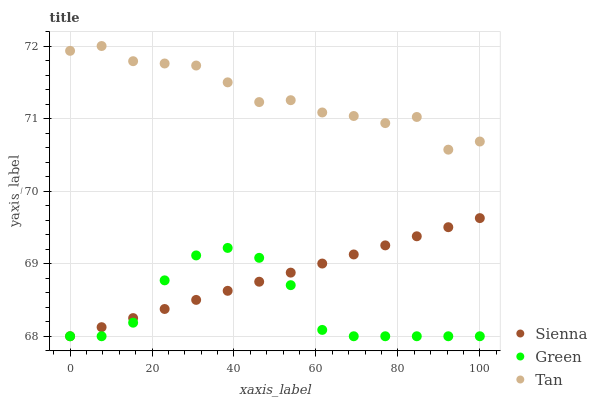Does Green have the minimum area under the curve?
Answer yes or no. Yes. Does Tan have the maximum area under the curve?
Answer yes or no. Yes. Does Tan have the minimum area under the curve?
Answer yes or no. No. Does Green have the maximum area under the curve?
Answer yes or no. No. Is Sienna the smoothest?
Answer yes or no. Yes. Is Tan the roughest?
Answer yes or no. Yes. Is Green the smoothest?
Answer yes or no. No. Is Green the roughest?
Answer yes or no. No. Does Sienna have the lowest value?
Answer yes or no. Yes. Does Tan have the lowest value?
Answer yes or no. No. Does Tan have the highest value?
Answer yes or no. Yes. Does Green have the highest value?
Answer yes or no. No. Is Sienna less than Tan?
Answer yes or no. Yes. Is Tan greater than Sienna?
Answer yes or no. Yes. Does Green intersect Sienna?
Answer yes or no. Yes. Is Green less than Sienna?
Answer yes or no. No. Is Green greater than Sienna?
Answer yes or no. No. Does Sienna intersect Tan?
Answer yes or no. No. 